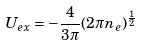Convert formula to latex. <formula><loc_0><loc_0><loc_500><loc_500>U _ { e x } = - \frac { 4 } { 3 \pi } ( 2 \pi n _ { e } ) ^ { \frac { 1 } { 2 } }</formula> 